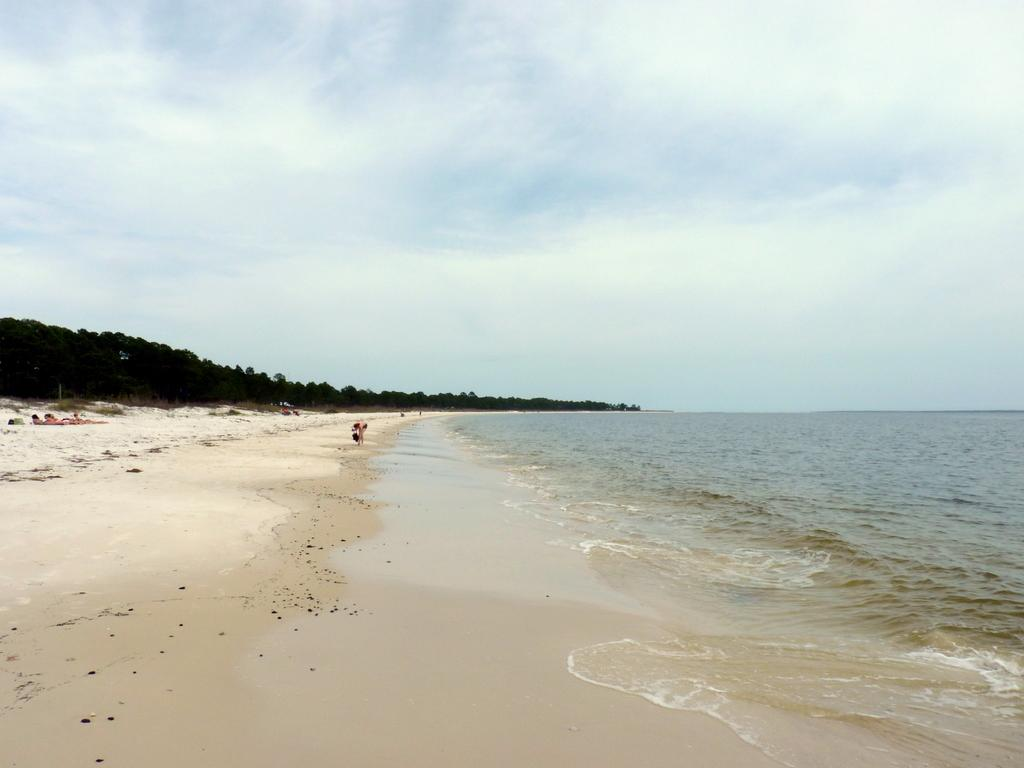What type of natural environment is depicted in the image? There is a sea shore in the image. What can be seen in the foreground of the image? Water is visible in the foreground of the image. What is visible in the background of the image? There are trees, people, and the sky visible in the background of the image. What type of health advice can be found on the scale in the image? There is no scale present in the image, and therefore no health advice can be found. 